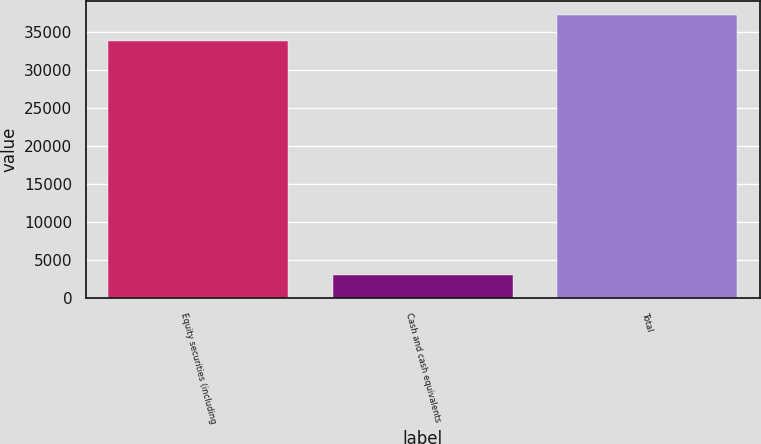Convert chart to OTSL. <chart><loc_0><loc_0><loc_500><loc_500><bar_chart><fcel>Equity securities (including<fcel>Cash and cash equivalents<fcel>Total<nl><fcel>33880<fcel>3045<fcel>37268<nl></chart> 